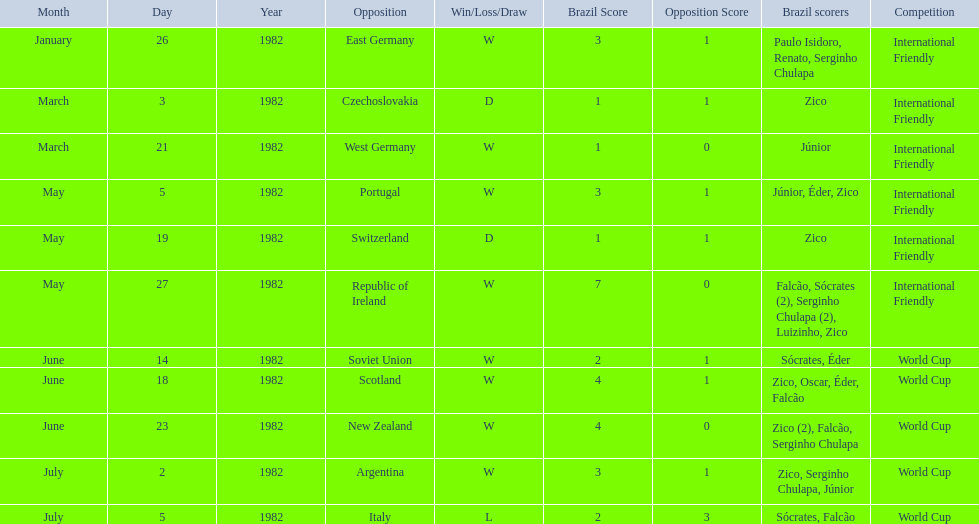What are the dates? January 26, 1982, March 3, 1982, March 21, 1982, May 5, 1982, May 19, 1982, May 27, 1982, June 14, 1982, June 18, 1982, June 23, 1982, July 2, 1982, July 5, 1982. And which date is listed first? January 26, 1982. 